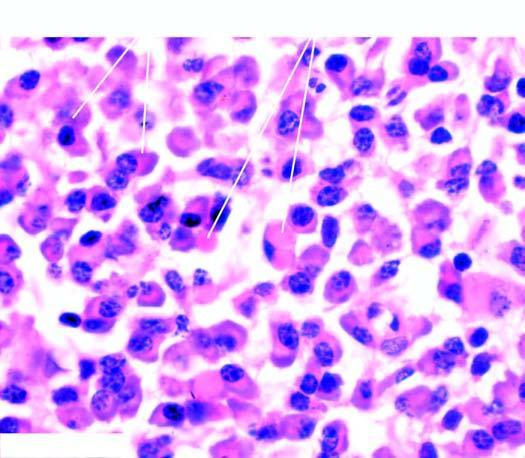what does the cytoplasm show due to accumulated immunoglobulins?
Answer the question using a single word or phrase. Pink homogeneous globular material immunoglobulins 